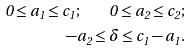<formula> <loc_0><loc_0><loc_500><loc_500>0 \leq a _ { 1 } \leq c _ { 1 } ; \quad 0 \leq a _ { 2 } \leq c _ { 2 } ; \\ - a _ { 2 } \leq \delta \leq c _ { 1 } - a _ { 1 } .</formula> 